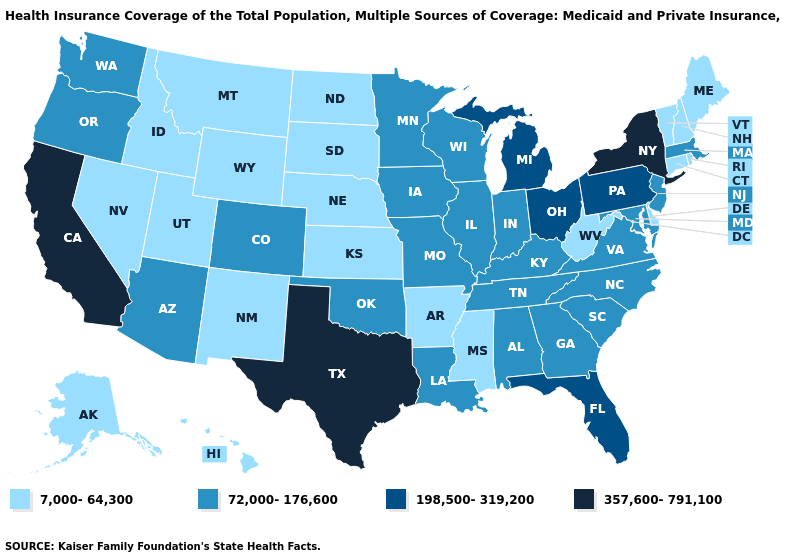Is the legend a continuous bar?
Concise answer only. No. What is the value of Massachusetts?
Answer briefly. 72,000-176,600. What is the lowest value in the South?
Give a very brief answer. 7,000-64,300. Name the states that have a value in the range 72,000-176,600?
Concise answer only. Alabama, Arizona, Colorado, Georgia, Illinois, Indiana, Iowa, Kentucky, Louisiana, Maryland, Massachusetts, Minnesota, Missouri, New Jersey, North Carolina, Oklahoma, Oregon, South Carolina, Tennessee, Virginia, Washington, Wisconsin. Among the states that border New York , does Pennsylvania have the lowest value?
Keep it brief. No. What is the value of Arizona?
Be succinct. 72,000-176,600. What is the value of Utah?
Short answer required. 7,000-64,300. Name the states that have a value in the range 198,500-319,200?
Be succinct. Florida, Michigan, Ohio, Pennsylvania. What is the highest value in the West ?
Write a very short answer. 357,600-791,100. What is the value of Arkansas?
Short answer required. 7,000-64,300. What is the lowest value in the West?
Give a very brief answer. 7,000-64,300. What is the lowest value in the West?
Give a very brief answer. 7,000-64,300. Does Kansas have the lowest value in the MidWest?
Quick response, please. Yes. Does the map have missing data?
Answer briefly. No. 